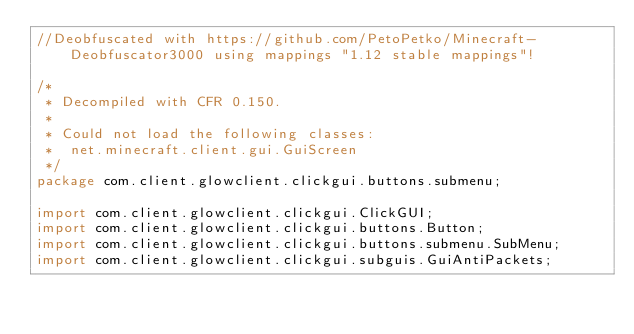Convert code to text. <code><loc_0><loc_0><loc_500><loc_500><_Java_>//Deobfuscated with https://github.com/PetoPetko/Minecraft-Deobfuscator3000 using mappings "1.12 stable mappings"!

/*
 * Decompiled with CFR 0.150.
 * 
 * Could not load the following classes:
 *  net.minecraft.client.gui.GuiScreen
 */
package com.client.glowclient.clickgui.buttons.submenu;

import com.client.glowclient.clickgui.ClickGUI;
import com.client.glowclient.clickgui.buttons.Button;
import com.client.glowclient.clickgui.buttons.submenu.SubMenu;
import com.client.glowclient.clickgui.subguis.GuiAntiPackets;</code> 